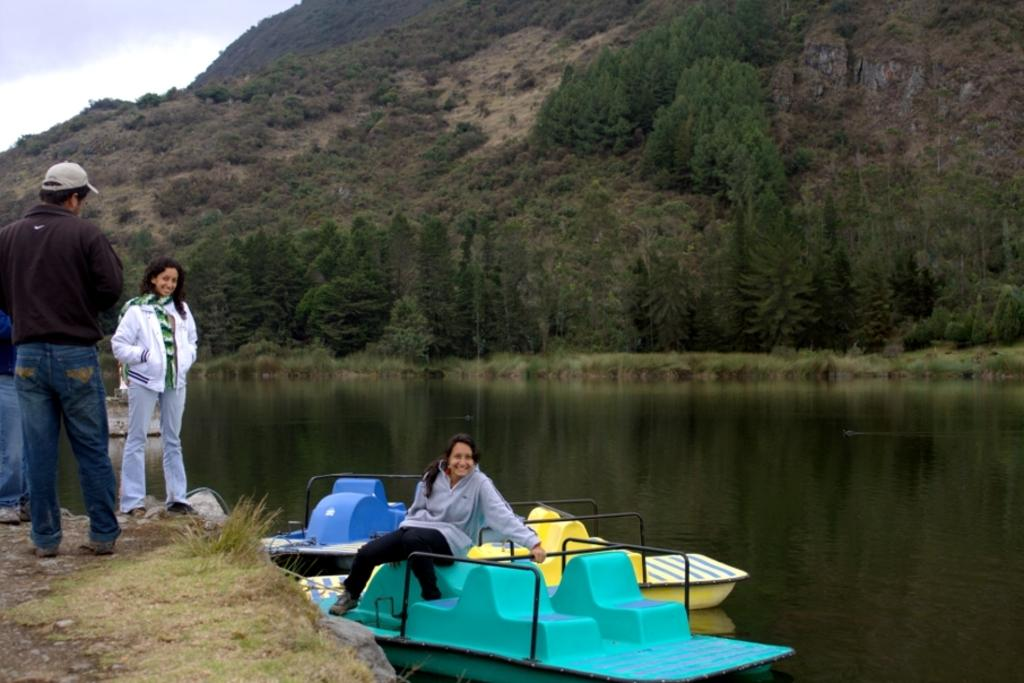How many people are on the boat in the image? There are three people standing on the boat and one woman sitting on the boat, making a total of four people. What is the position of the boat in relation to the water? The boat is above the water in the image. What can be seen in the background of the image? There are trees, grass, a hill, and the sky visible in the background of the image. Who is the manager of the boat in the image? There is no mention of a manager in the image, as it only shows people on a boat and the surrounding environment. 